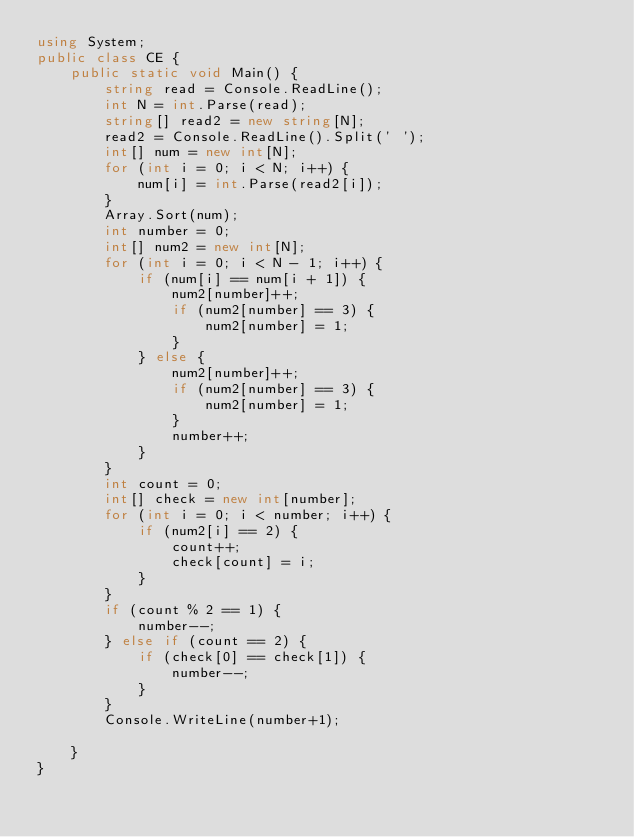<code> <loc_0><loc_0><loc_500><loc_500><_C#_>using System;
public class CE {
    public static void Main() {
        string read = Console.ReadLine();
        int N = int.Parse(read);
        string[] read2 = new string[N];
        read2 = Console.ReadLine().Split(' ');
        int[] num = new int[N];
        for (int i = 0; i < N; i++) {
            num[i] = int.Parse(read2[i]);
        }
        Array.Sort(num);
        int number = 0;
        int[] num2 = new int[N];
        for (int i = 0; i < N - 1; i++) {
            if (num[i] == num[i + 1]) {
                num2[number]++;
                if (num2[number] == 3) {
                    num2[number] = 1;
                }
            } else {
                num2[number]++;
                if (num2[number] == 3) {
                    num2[number] = 1;
                }
                number++;
            }
        }
        int count = 0;
        int[] check = new int[number];
        for (int i = 0; i < number; i++) {
            if (num2[i] == 2) {
                count++;
                check[count] = i;
            }
        }
        if (count % 2 == 1) {
            number--;
        } else if (count == 2) {
            if (check[0] == check[1]) {
                number--;
            }
        }
        Console.WriteLine(number+1);

    }
}</code> 